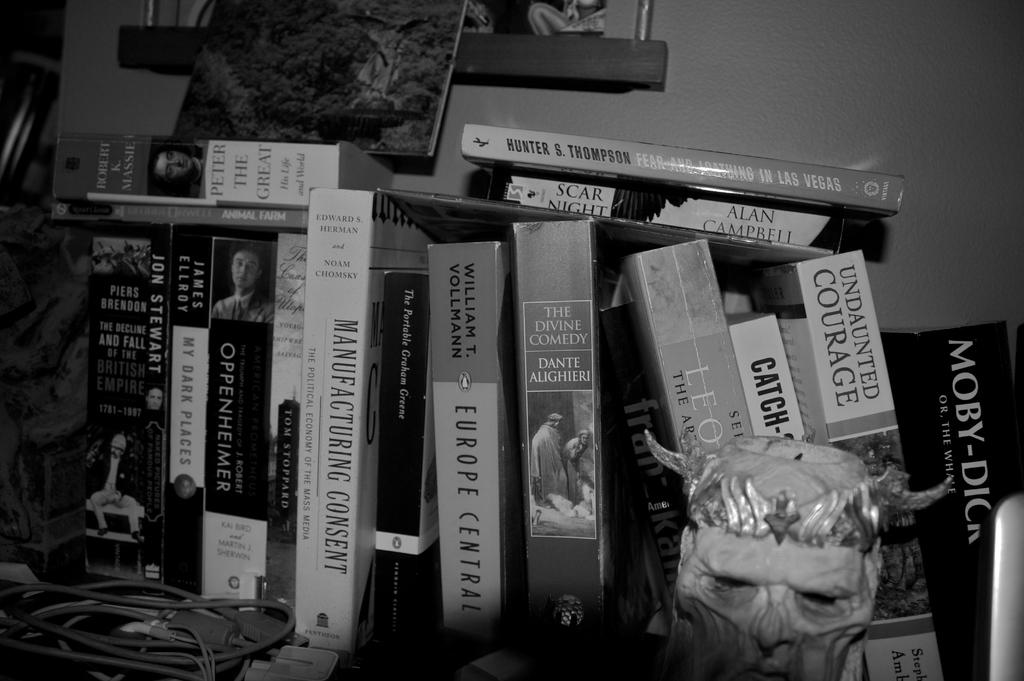<image>
Summarize the visual content of the image. The book on the far right is Moby-Dick 